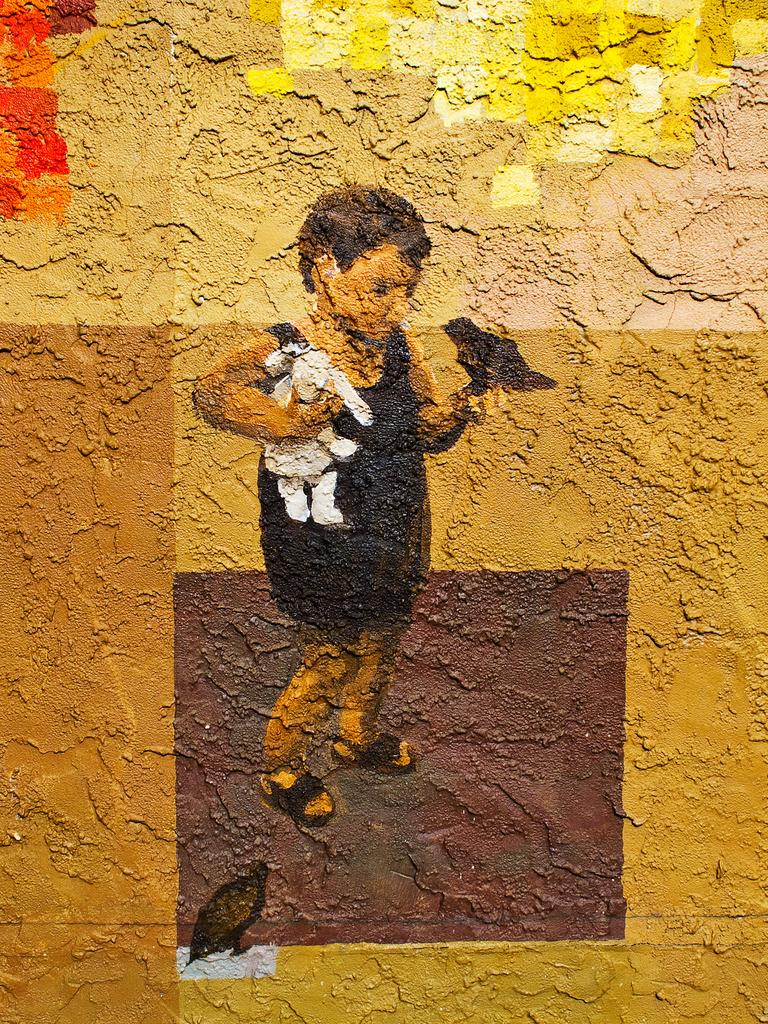What is on the wall in the image? There is a painting on the wall. What is the subject of the painting? The painting depicts a boy. What is the boy holding in the painting? The boy is holding a toy in the painting. Are there any other elements in the painting besides the boy? Yes, there are birds in the painting. What type of riddle does the painting pose to the viewer? The painting does not pose a riddle to the viewer; it is a visual representation of a boy holding a toy and surrounded by birds. What process is depicted in the painting? The painting does not depict a process; it is a static image of a boy and birds. 